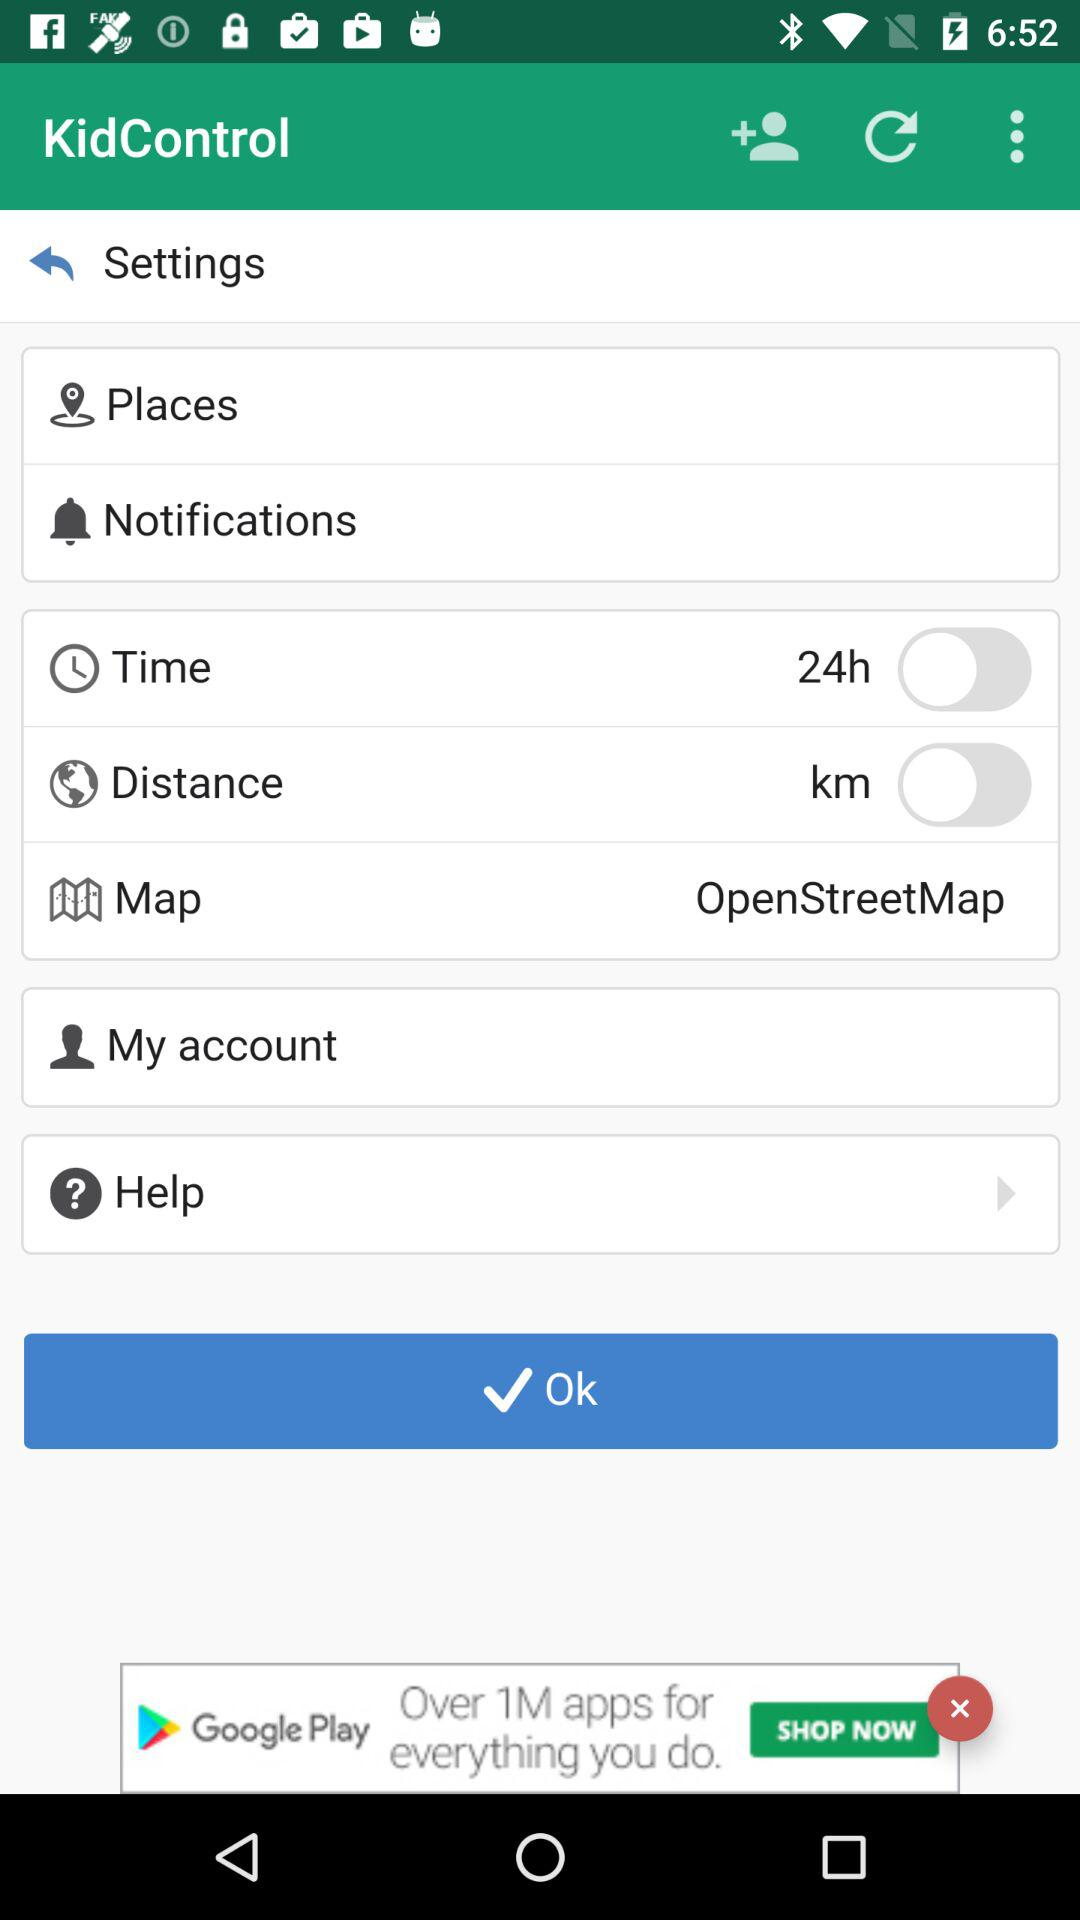What is the time format? The time format is 24 hours. 